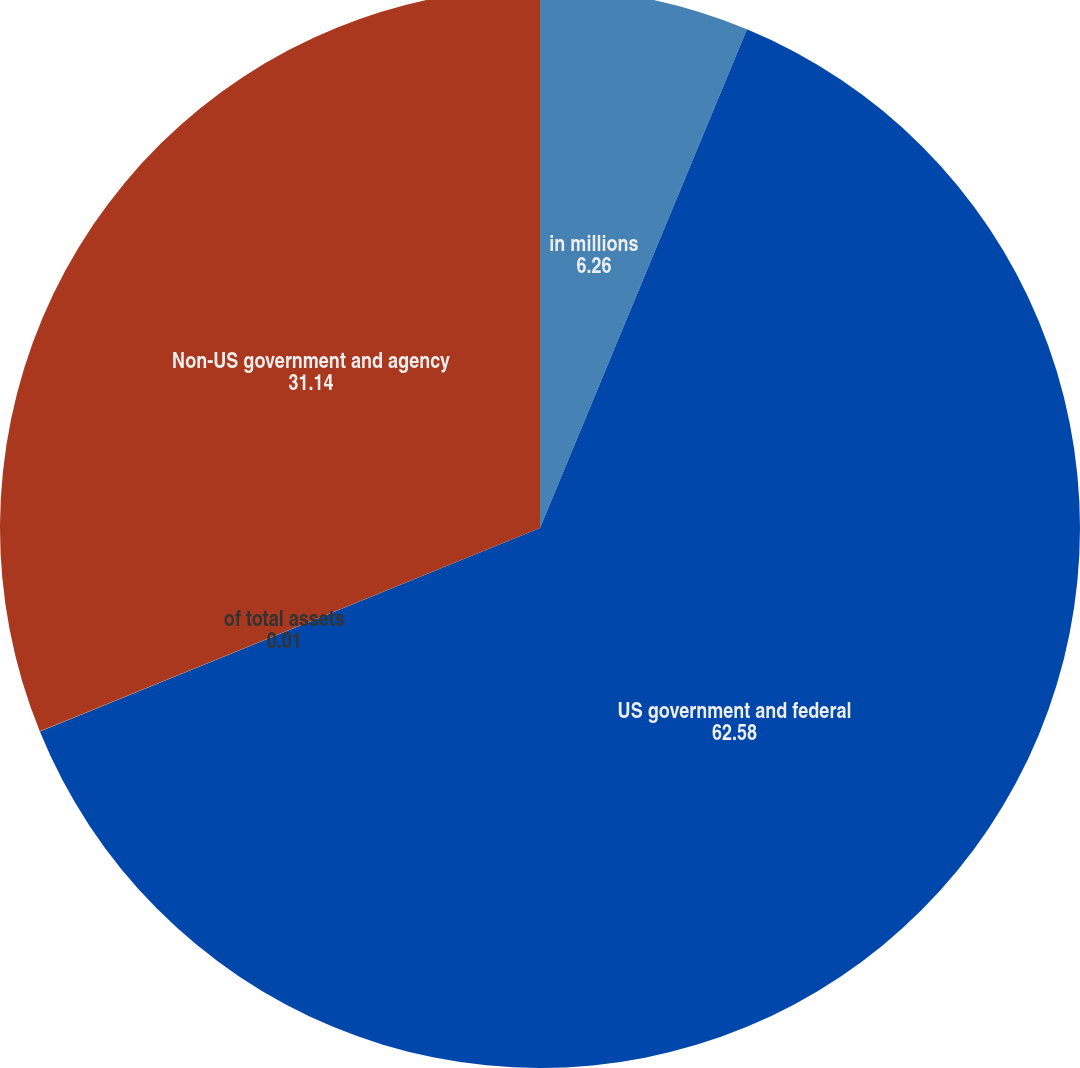<chart> <loc_0><loc_0><loc_500><loc_500><pie_chart><fcel>in millions<fcel>US government and federal<fcel>of total assets<fcel>Non-US government and agency<nl><fcel>6.26%<fcel>62.58%<fcel>0.01%<fcel>31.14%<nl></chart> 